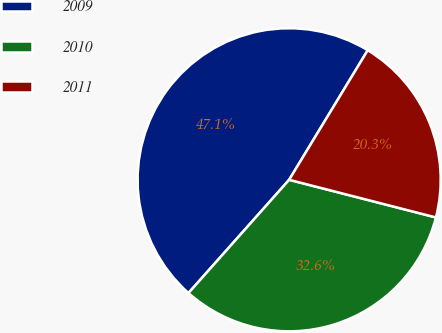Convert chart. <chart><loc_0><loc_0><loc_500><loc_500><pie_chart><fcel>2009<fcel>2010<fcel>2011<nl><fcel>47.11%<fcel>32.57%<fcel>20.32%<nl></chart> 